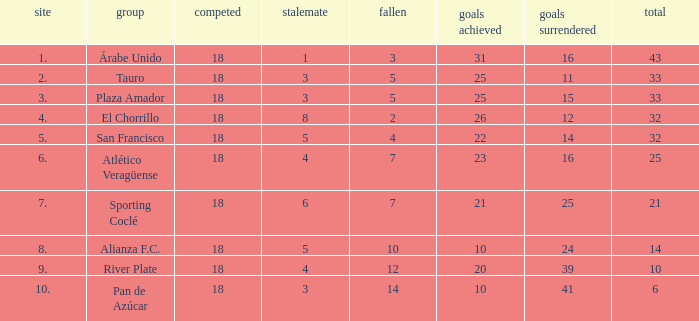How many goals were conceded by teams with 32 points, more than 2 losses and more than 22 goals scored? 0.0. 